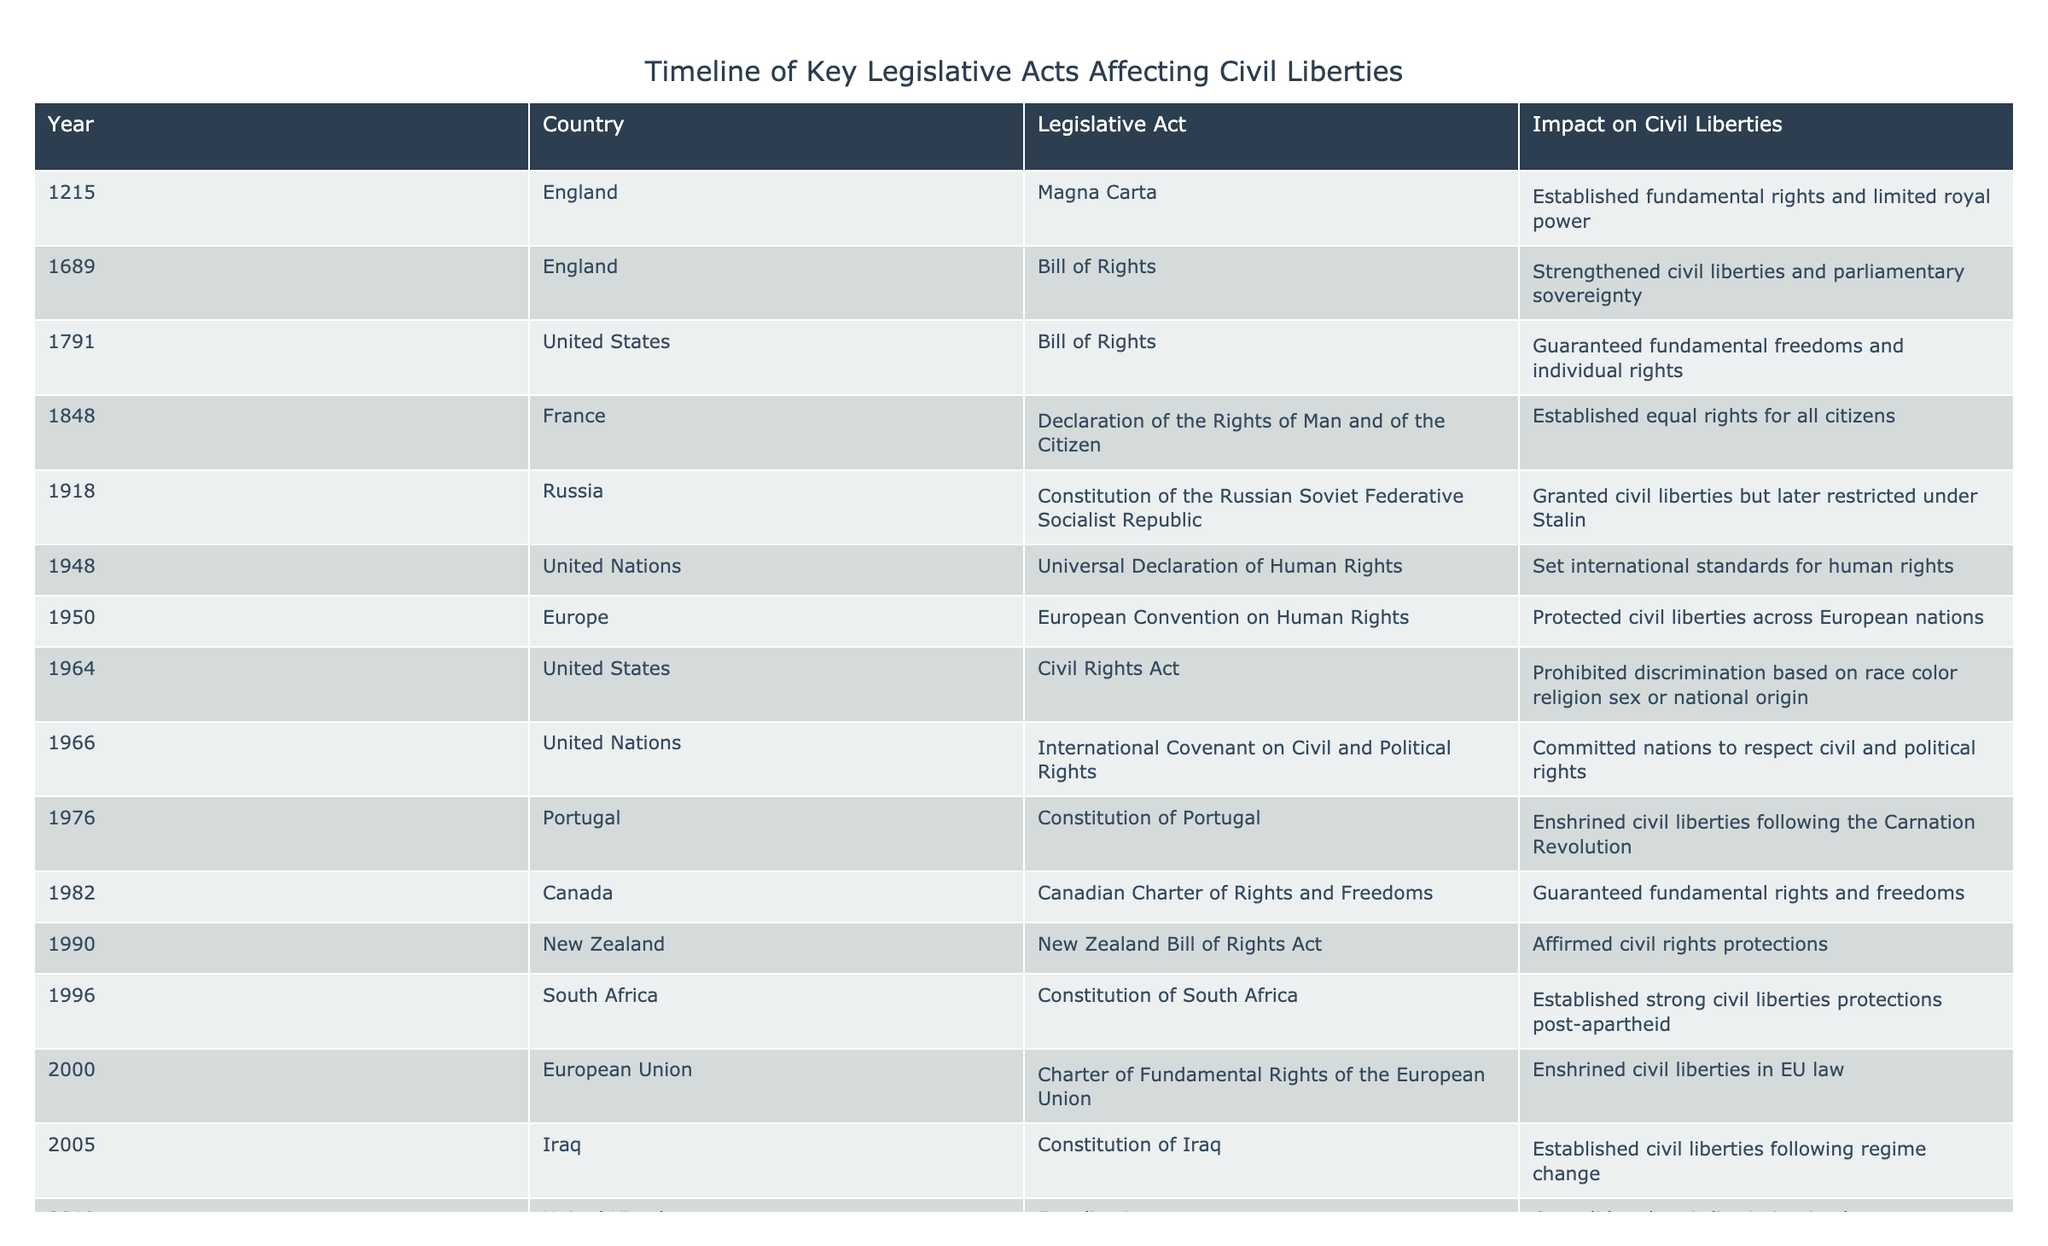What year was the Civil Rights Act passed in the United States? The table lists the Civil Rights Act under the United States with the corresponding year of 1964.
Answer: 1964 What impact did the Universal Declaration of Human Rights have? According to the table, the Universal Declaration of Human Rights set international standards for human rights.
Answer: Set international standards for human rights How many legislative acts are listed for England? The table shows two acts for England: the Magna Carta (1215) and the Bill of Rights (1689), which makes it a total of 2.
Answer: 2 Which legislative act granted civil liberties in South Africa? The Constitution of South Africa passed in 1996 established strong civil liberties protections post-apartheid according to the table.
Answer: Constitution of South Africa What is the latest legislative act affecting civil liberties listed in the table? The table indicates that the latest act is the Civil Code in Vietnam from 2015.
Answer: Civil Code Are there any legislative acts listed that were passed in the 20th century? Yes, several acts are listed in the 20th century, including the Civil Rights Act (1964) and the Constitution of South Africa (1996).
Answer: Yes Which country enacted a Bill of Rights in 1982? The table shows that Canada enacted its Canadian Charter of Rights and Freedoms in 1982.
Answer: Canada According to the table, did the Citizenship Amendment Act have a positive or controversial effect? The table notes that the Citizenship Amendment Act from India in 2019 is described as controversial, indicating mixed reactions.
Answer: Controversial What was the impact of the Bill of Rights passed in 1791 in the United States? The Bill of Rights in 1791 guaranteed fundamental freedoms and individual rights according to the table.
Answer: Guaranteed fundamental freedoms and individual rights How many acts are related to the European Union listed in the table? The table lists one act related to the European Union, which is the Charter of Fundamental Rights of the European Union from 2000.
Answer: 1 What year marks the establishment of the United Nations' International Covenant on Civil and Political Rights? The table shows that the International Covenant on Civil and Political Rights was established in 1966.
Answer: 1966 Which legislative act was established after a regime change in Iraq? The Constitution of Iraq, established in 2005, is noted for establishing civil liberties following regime change in the table.
Answer: Constitution of Iraq Is there an act listed that emphasizes a declaration of rights? Yes, both the Declaration of the Rights of Man and of the Citizen (1848) in France and the Universal Declaration of Human Rights (1948) emphasize declarations of rights.
Answer: Yes How many acts were passed in the 21st century according to the table? The table indicates three acts were passed in the 21st century: the Constitution of Iraq (2005), the Equality Act in the United Kingdom (2010), and the Civil Code in Vietnam (2015).
Answer: 3 Which legislative act is linked with the Carnation Revolution in Portugal? The Constitution of Portugal, enacted in 1976, is linked with the Carnation Revolution according to the table.
Answer: Constitution of Portugal 